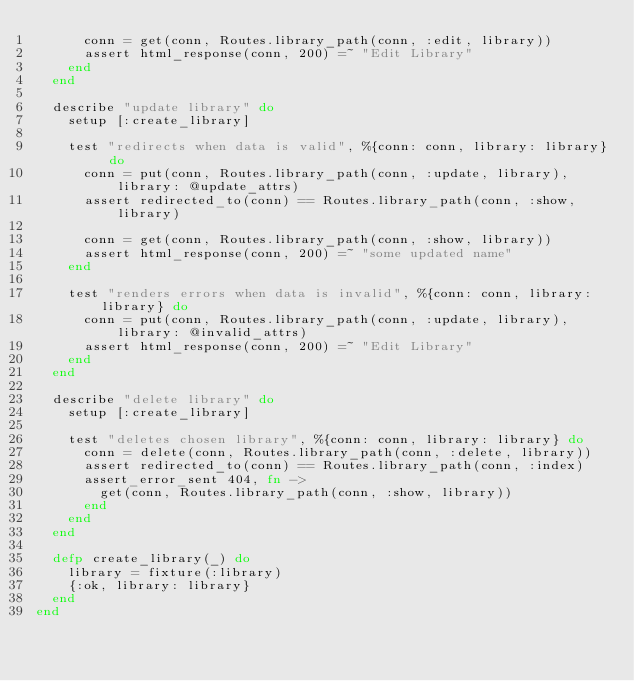<code> <loc_0><loc_0><loc_500><loc_500><_Elixir_>      conn = get(conn, Routes.library_path(conn, :edit, library))
      assert html_response(conn, 200) =~ "Edit Library"
    end
  end

  describe "update library" do
    setup [:create_library]

    test "redirects when data is valid", %{conn: conn, library: library} do
      conn = put(conn, Routes.library_path(conn, :update, library), library: @update_attrs)
      assert redirected_to(conn) == Routes.library_path(conn, :show, library)

      conn = get(conn, Routes.library_path(conn, :show, library))
      assert html_response(conn, 200) =~ "some updated name"
    end

    test "renders errors when data is invalid", %{conn: conn, library: library} do
      conn = put(conn, Routes.library_path(conn, :update, library), library: @invalid_attrs)
      assert html_response(conn, 200) =~ "Edit Library"
    end
  end

  describe "delete library" do
    setup [:create_library]

    test "deletes chosen library", %{conn: conn, library: library} do
      conn = delete(conn, Routes.library_path(conn, :delete, library))
      assert redirected_to(conn) == Routes.library_path(conn, :index)
      assert_error_sent 404, fn ->
        get(conn, Routes.library_path(conn, :show, library))
      end
    end
  end

  defp create_library(_) do
    library = fixture(:library)
    {:ok, library: library}
  end
end
</code> 